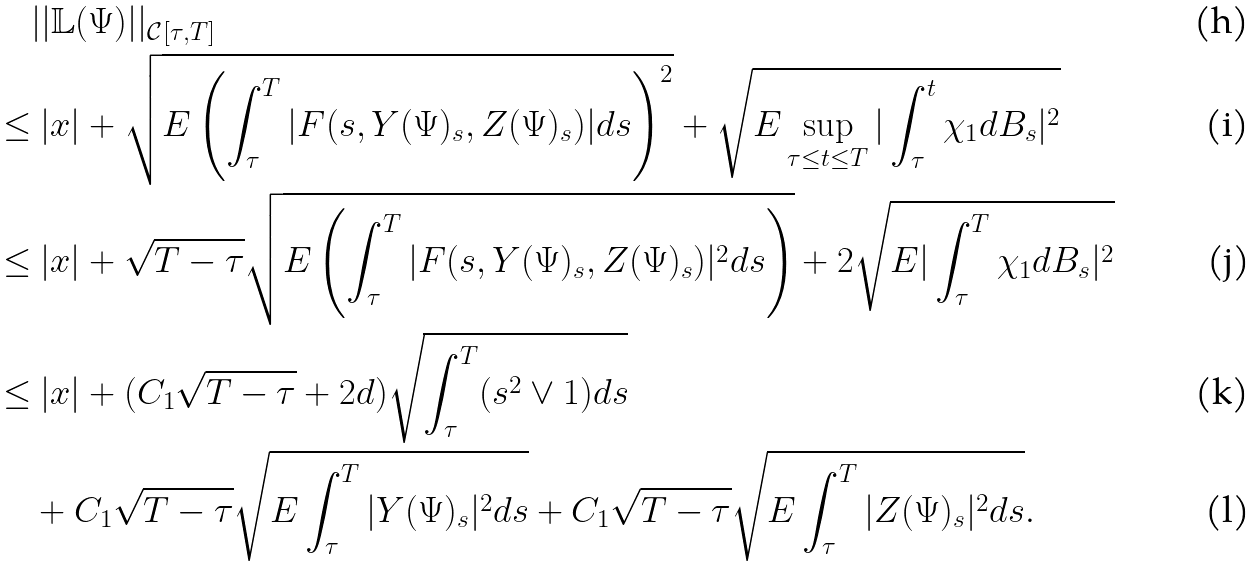Convert formula to latex. <formula><loc_0><loc_0><loc_500><loc_500>& | | \mathbb { L } ( \Psi ) | | _ { \mathcal { C } [ \tau , T ] } \\ \leq & \ | x | + \sqrt { E \left ( \int _ { \tau } ^ { T } | F ( s , Y ( \Psi ) _ { s } , Z ( \Psi ) _ { s } ) | d s \right ) ^ { 2 } } + \sqrt { E \sup _ { \tau \leq t \leq T } | \int _ { \tau } ^ { t } \chi _ { 1 } d B _ { s } | ^ { 2 } } \\ \leq & \ | x | + \sqrt { T - \tau } \sqrt { E \left ( \int _ { \tau } ^ { T } | F ( s , Y ( \Psi ) _ { s } , Z ( \Psi ) _ { s } ) | ^ { 2 } d s \right ) } + 2 \sqrt { E | \int _ { \tau } ^ { T } \chi _ { 1 } d B _ { s } | ^ { 2 } } \\ \leq & \ | x | + ( C _ { 1 } \sqrt { T - \tau } + 2 d ) \sqrt { \int _ { \tau } ^ { T } ( s ^ { 2 } \vee 1 ) d s } \\ & + C _ { 1 } \sqrt { T - \tau } \sqrt { E \int _ { \tau } ^ { T } | Y ( \Psi ) _ { s } | ^ { 2 } d s } + C _ { 1 } \sqrt { T - \tau } \sqrt { E \int _ { \tau } ^ { T } | Z ( \Psi ) _ { s } | ^ { 2 } d s } .</formula> 